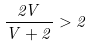<formula> <loc_0><loc_0><loc_500><loc_500>\frac { 2 V } { V + 2 } > 2</formula> 